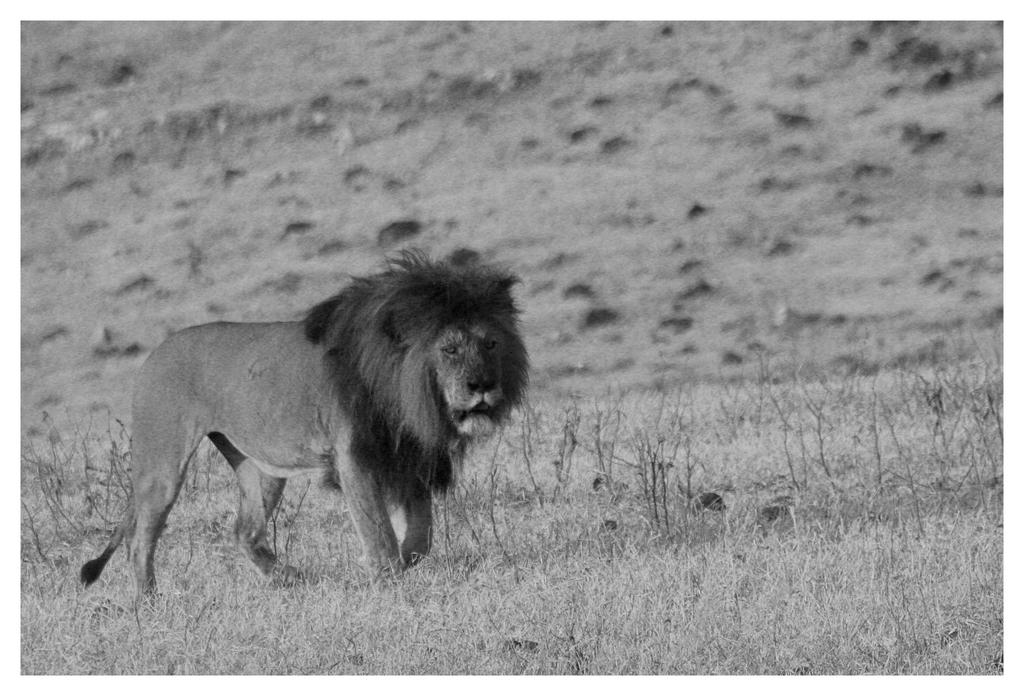What is the color scheme of the image? The image is black and white. What animal can be seen in the image? There is a lion in the image. What is the lion doing in the image? The lion is walking on the grassland. What type of cheese is being served at the school in the image? There is no school or cheese present in the image; it features a black and white image of a lion walking on the grassland. 